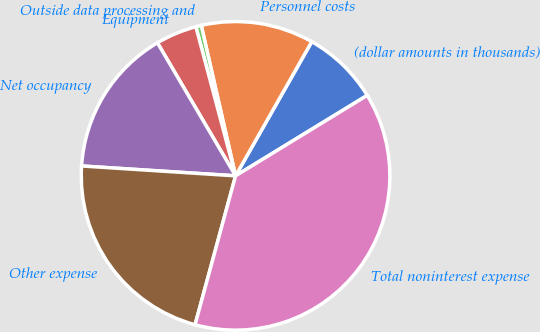Convert chart to OTSL. <chart><loc_0><loc_0><loc_500><loc_500><pie_chart><fcel>(dollar amounts in thousands)<fcel>Personnel costs<fcel>Outside data processing and<fcel>Equipment<fcel>Net occupancy<fcel>Other expense<fcel>Total noninterest expense<nl><fcel>8.05%<fcel>11.79%<fcel>0.57%<fcel>4.31%<fcel>15.53%<fcel>21.79%<fcel>37.96%<nl></chart> 